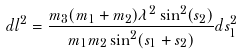<formula> <loc_0><loc_0><loc_500><loc_500>d l ^ { 2 } = \frac { m _ { 3 } ( m _ { 1 } + m _ { 2 } ) \lambda ^ { 2 } \sin ^ { 2 } ( s _ { 2 } ) } { m _ { 1 } m _ { 2 } \sin ^ { 2 } ( s _ { 1 } + s _ { 2 } ) } d s _ { 1 } ^ { 2 }</formula> 